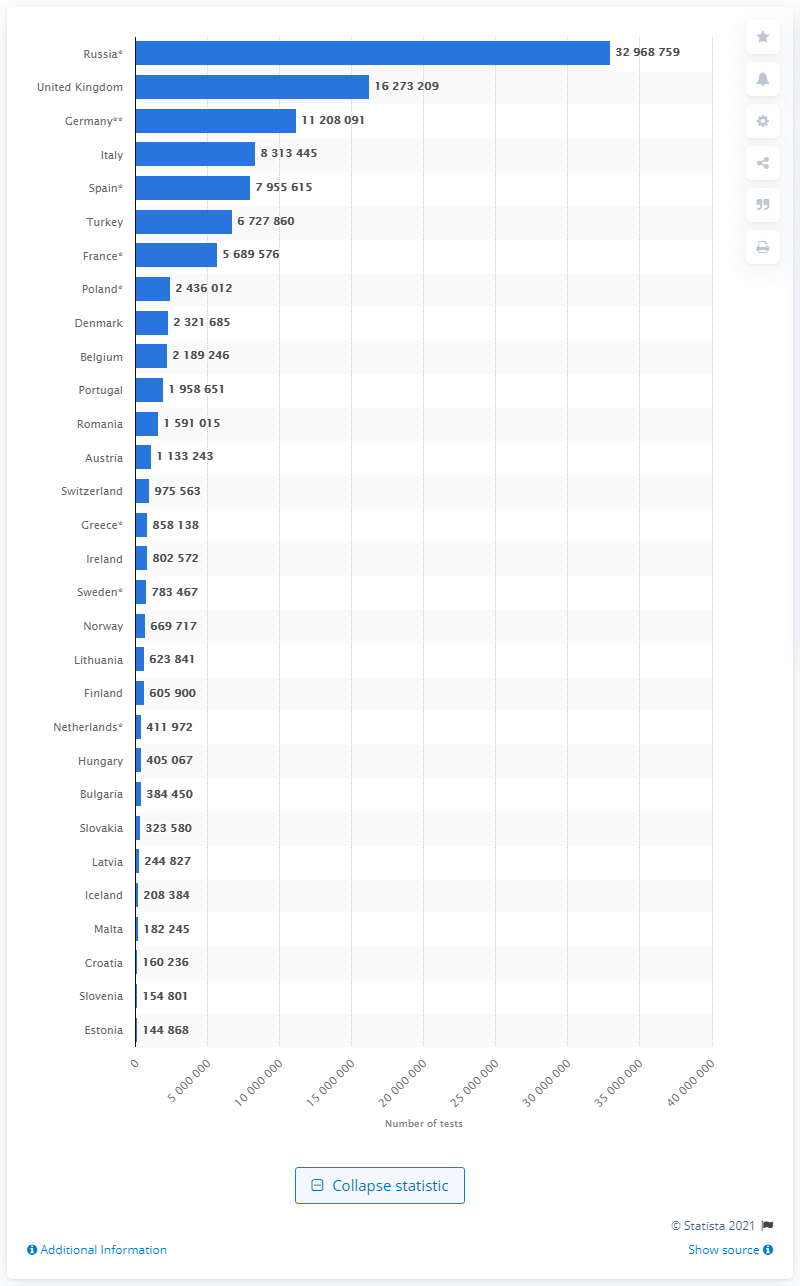Specify some key components in this picture. As of February 22, 2023, a total of 11,208,091 COVID-19 tests have been performed in Germany. As of August 27, 2020, a total of 16,273,209 coronavirus tests had been conducted in the UK. As of August 27, 2020, a total of 329,687,591 coronavirus tests had been conducted in Russia. 